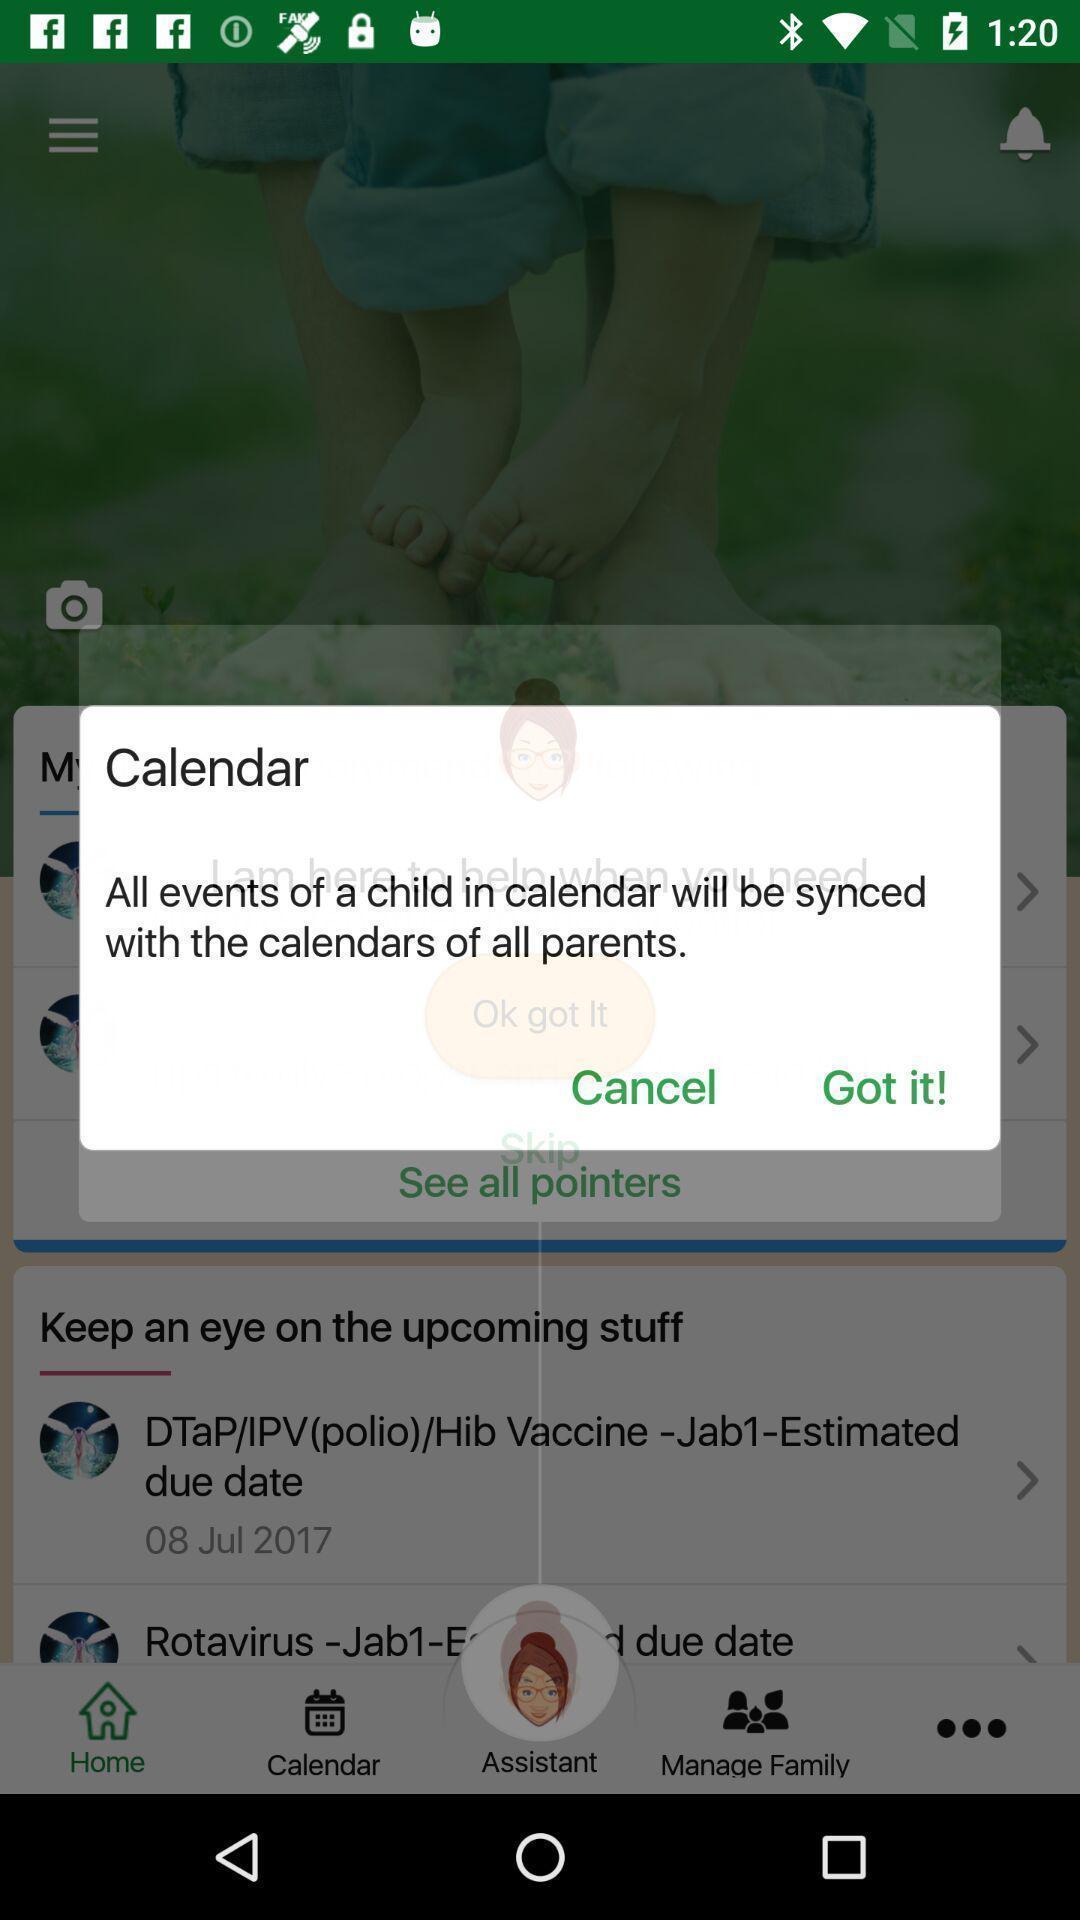Tell me what you see in this picture. Pop-up shows calendar. 